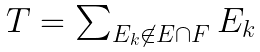Convert formula to latex. <formula><loc_0><loc_0><loc_500><loc_500>\begin{array} { l } T = \sum _ { E _ { k } \not \in E \cap F } E _ { k } \end{array}</formula> 